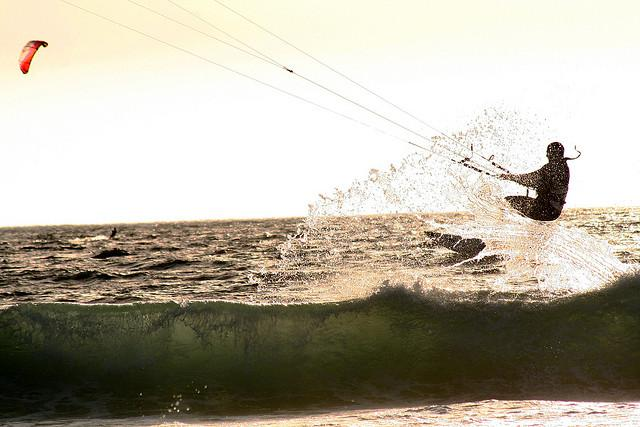The canopy wing is used for? flight 